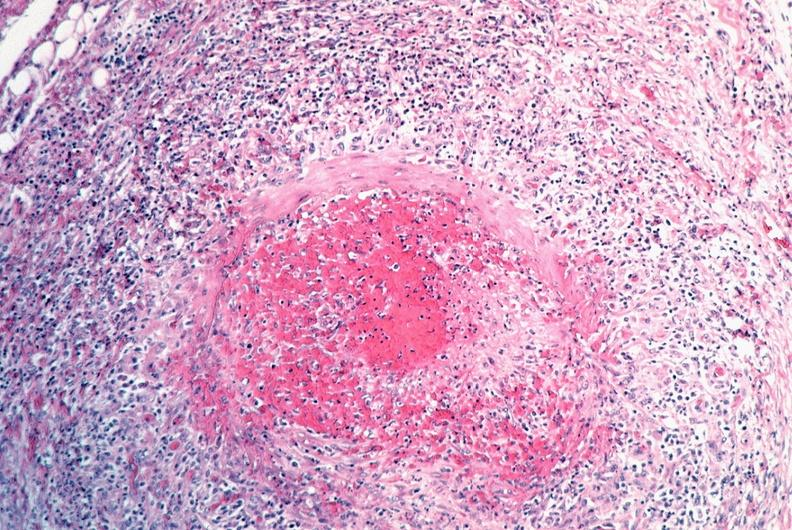where is this from?
Answer the question using a single word or phrase. Vasculature 